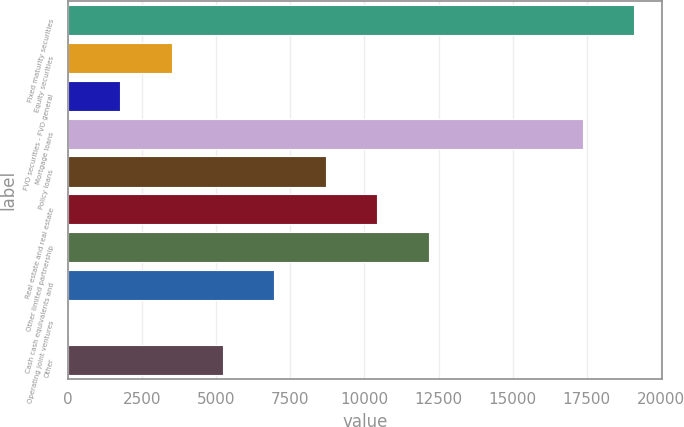Convert chart to OTSL. <chart><loc_0><loc_0><loc_500><loc_500><bar_chart><fcel>Fixed maturity securities<fcel>Equity securities<fcel>FVO securities - FVO general<fcel>Mortgage loans<fcel>Policy loans<fcel>Real estate and real estate<fcel>Other limited partnership<fcel>Cash cash equivalents and<fcel>Operating joint ventures<fcel>Other<nl><fcel>19096.5<fcel>3495<fcel>1761.5<fcel>17363<fcel>8695.5<fcel>10429<fcel>12162.5<fcel>6962<fcel>28<fcel>5228.5<nl></chart> 